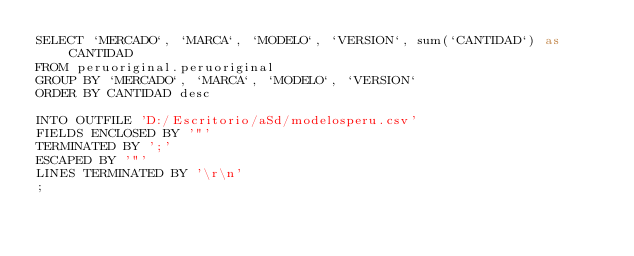Convert code to text. <code><loc_0><loc_0><loc_500><loc_500><_SQL_>SELECT `MERCADO`, `MARCA`, `MODELO`, `VERSION`, sum(`CANTIDAD`) as CANTIDAD
FROM peruoriginal.peruoriginal
GROUP BY `MERCADO`, `MARCA`, `MODELO`, `VERSION`
ORDER BY CANTIDAD desc

INTO OUTFILE 'D:/Escritorio/aSd/modelosperu.csv' 
FIELDS ENCLOSED BY '"' 
TERMINATED BY ';' 
ESCAPED BY '"' 
LINES TERMINATED BY '\r\n'
;</code> 